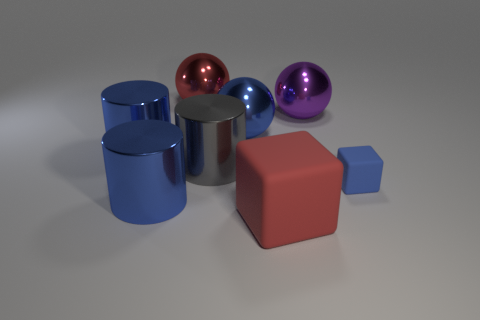Subtract all big blue balls. How many balls are left? 2 Add 1 cylinders. How many objects exist? 9 Subtract 1 cylinders. How many cylinders are left? 2 Subtract all balls. How many objects are left? 5 Subtract all red spheres. How many spheres are left? 2 Subtract all red cylinders. How many red blocks are left? 1 Add 4 large balls. How many large balls are left? 7 Add 4 small rubber things. How many small rubber things exist? 5 Subtract 0 red cylinders. How many objects are left? 8 Subtract all red spheres. Subtract all green cubes. How many spheres are left? 2 